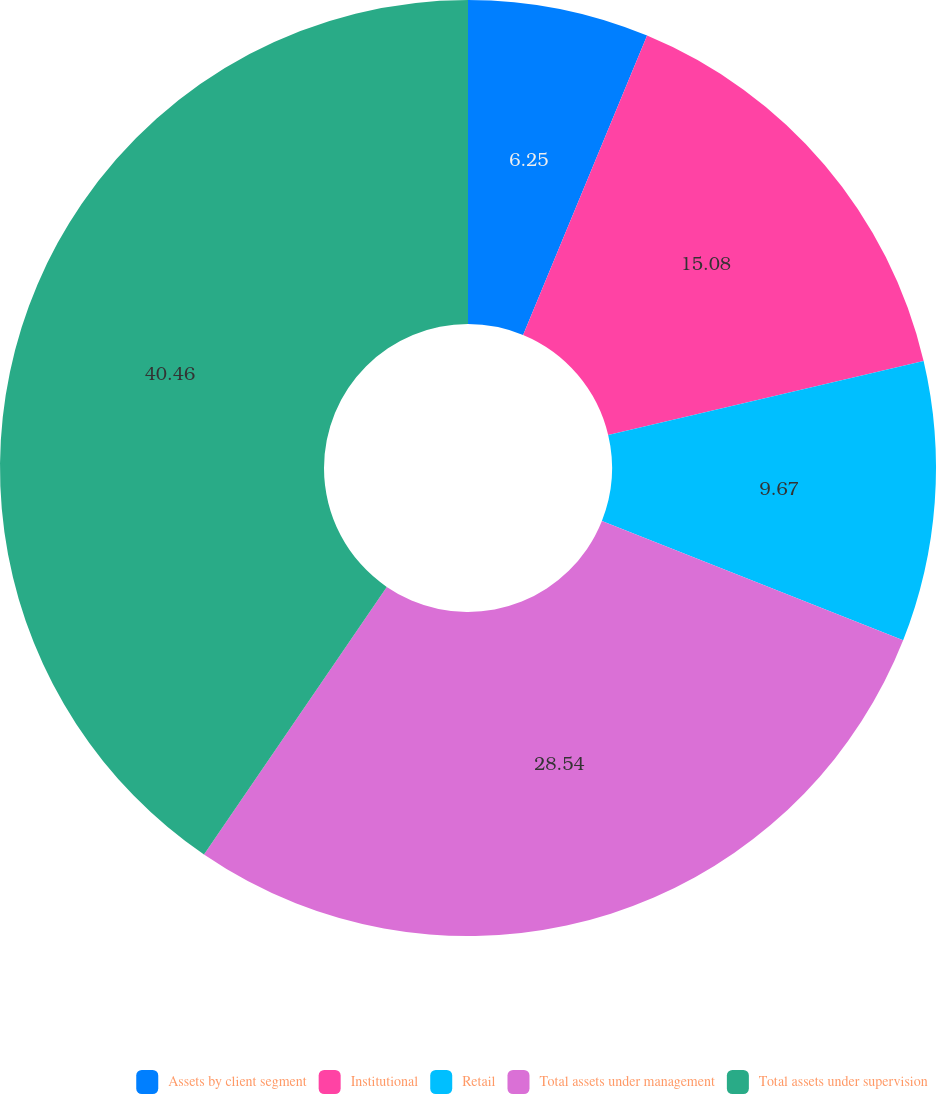Convert chart to OTSL. <chart><loc_0><loc_0><loc_500><loc_500><pie_chart><fcel>Assets by client segment<fcel>Institutional<fcel>Retail<fcel>Total assets under management<fcel>Total assets under supervision<nl><fcel>6.25%<fcel>15.08%<fcel>9.67%<fcel>28.54%<fcel>40.46%<nl></chart> 